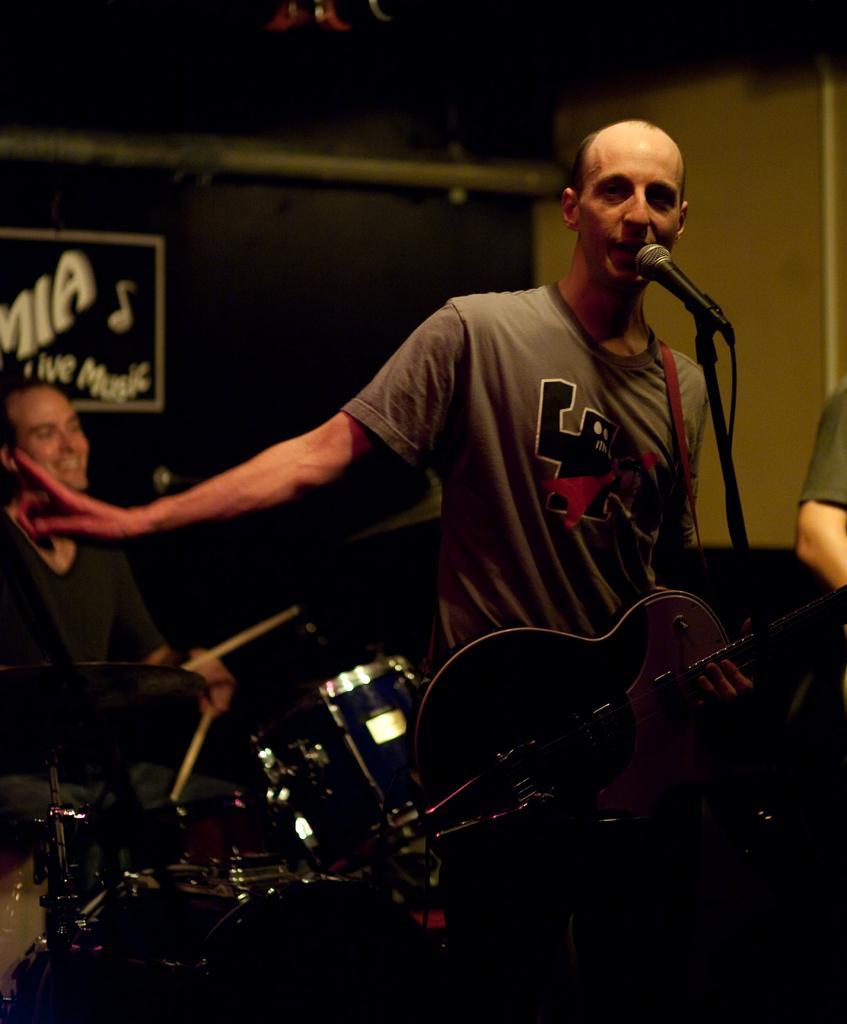Can you describe this image briefly? In this picture there is a man who is singing on the mic and holding a guitar. Beside him I can see the person's hand who is wearing t-shirt. On the left there is a man who is playing a drum and he is sitting on the chair. In the background I can see the board which is placed on the black wall. 